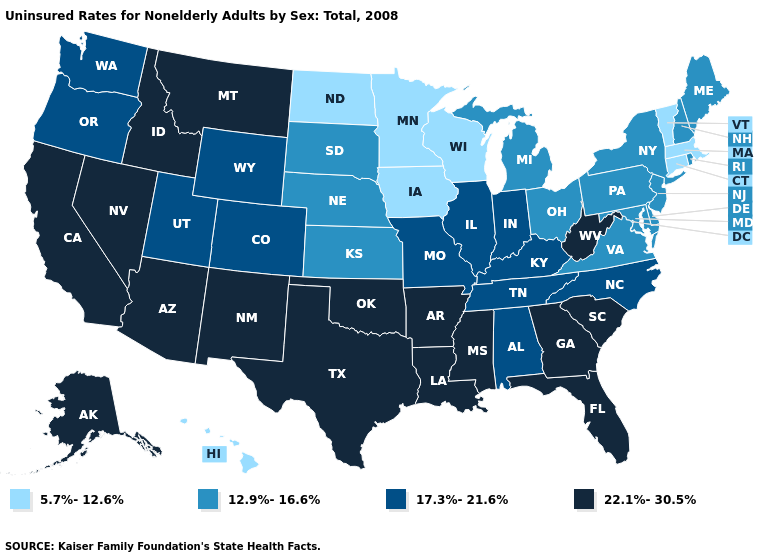Does Vermont have the highest value in the Northeast?
Write a very short answer. No. Does Wyoming have the highest value in the West?
Quick response, please. No. Among the states that border Michigan , does Ohio have the highest value?
Keep it brief. No. What is the highest value in states that border Mississippi?
Quick response, please. 22.1%-30.5%. Does the first symbol in the legend represent the smallest category?
Be succinct. Yes. Does Mississippi have the highest value in the South?
Keep it brief. Yes. Does Arizona have the highest value in the USA?
Quick response, please. Yes. Among the states that border Florida , which have the lowest value?
Keep it brief. Alabama. What is the lowest value in states that border Idaho?
Be succinct. 17.3%-21.6%. Is the legend a continuous bar?
Be succinct. No. What is the highest value in the South ?
Write a very short answer. 22.1%-30.5%. What is the highest value in the Northeast ?
Keep it brief. 12.9%-16.6%. Does Arizona have the same value as Hawaii?
Write a very short answer. No. Name the states that have a value in the range 5.7%-12.6%?
Give a very brief answer. Connecticut, Hawaii, Iowa, Massachusetts, Minnesota, North Dakota, Vermont, Wisconsin. What is the value of Minnesota?
Keep it brief. 5.7%-12.6%. 